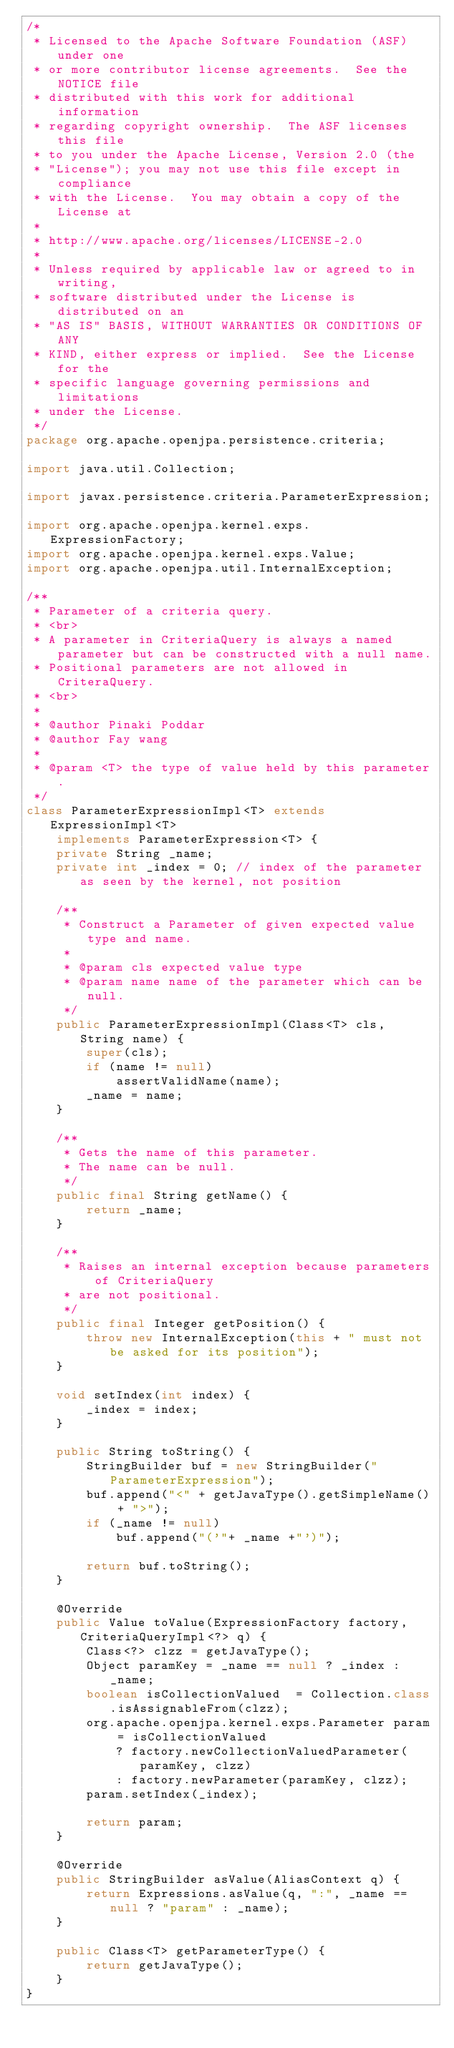Convert code to text. <code><loc_0><loc_0><loc_500><loc_500><_Java_>/*
 * Licensed to the Apache Software Foundation (ASF) under one
 * or more contributor license agreements.  See the NOTICE file
 * distributed with this work for additional information
 * regarding copyright ownership.  The ASF licenses this file
 * to you under the Apache License, Version 2.0 (the
 * "License"); you may not use this file except in compliance
 * with the License.  You may obtain a copy of the License at
 *
 * http://www.apache.org/licenses/LICENSE-2.0
 *
 * Unless required by applicable law or agreed to in writing,
 * software distributed under the License is distributed on an
 * "AS IS" BASIS, WITHOUT WARRANTIES OR CONDITIONS OF ANY
 * KIND, either express or implied.  See the License for the
 * specific language governing permissions and limitations
 * under the License.    
 */
package org.apache.openjpa.persistence.criteria;

import java.util.Collection;

import javax.persistence.criteria.ParameterExpression;

import org.apache.openjpa.kernel.exps.ExpressionFactory;
import org.apache.openjpa.kernel.exps.Value;
import org.apache.openjpa.util.InternalException;

/**
 * Parameter of a criteria query.
 * <br>
 * A parameter in CriteriaQuery is always a named parameter but can be constructed with a null name.
 * Positional parameters are not allowed in CriteraQuery.
 * <br> 
 * 
 * @author Pinaki Poddar
 * @author Fay wang
 * 
 * @param <T> the type of value held by this parameter.
 */
class ParameterExpressionImpl<T> extends ExpressionImpl<T> 
    implements ParameterExpression<T> {
    private String _name;
    private int _index = 0; // index of the parameter as seen by the kernel, not position
	
	/**
	 * Construct a Parameter of given expected value type and name.
	 * 
	 * @param cls expected value type
	 * @param name name of the parameter which can be null.
	 */
    public ParameterExpressionImpl(Class<T> cls, String name) {
        super(cls);
        if (name != null)
            assertValidName(name);
        _name = name;
    }

    /**
     * Gets the name of this parameter.
     * The name can be null.
     */
    public final String getName() {
        return _name;
    }
    
    /**
     * Raises an internal exception because parameters of CriteriaQuery
     * are not positional. 
     */
    public final Integer getPosition() {
        throw new InternalException(this + " must not be asked for its position");
    }
    
    void setIndex(int index) {
        _index = index;
    }
    
    public String toString() {
        StringBuilder buf = new StringBuilder("ParameterExpression");
        buf.append("<" + getJavaType().getSimpleName() + ">");
        if (_name != null)
            buf.append("('"+ _name +"')"); 

        return buf.toString();
    }
    
    @Override
    public Value toValue(ExpressionFactory factory, CriteriaQueryImpl<?> q) {
        Class<?> clzz = getJavaType();
        Object paramKey = _name == null ? _index : _name;
        boolean isCollectionValued  = Collection.class.isAssignableFrom(clzz);
        org.apache.openjpa.kernel.exps.Parameter param = isCollectionValued 
            ? factory.newCollectionValuedParameter(paramKey, clzz) 
            : factory.newParameter(paramKey, clzz);
        param.setIndex(_index);
        
        return param;
    }   
    
    @Override
    public StringBuilder asValue(AliasContext q) {
        return Expressions.asValue(q, ":", _name == null ? "param" : _name);
    }
    
    public Class<T> getParameterType() {
        return getJavaType();
    }
}
</code> 